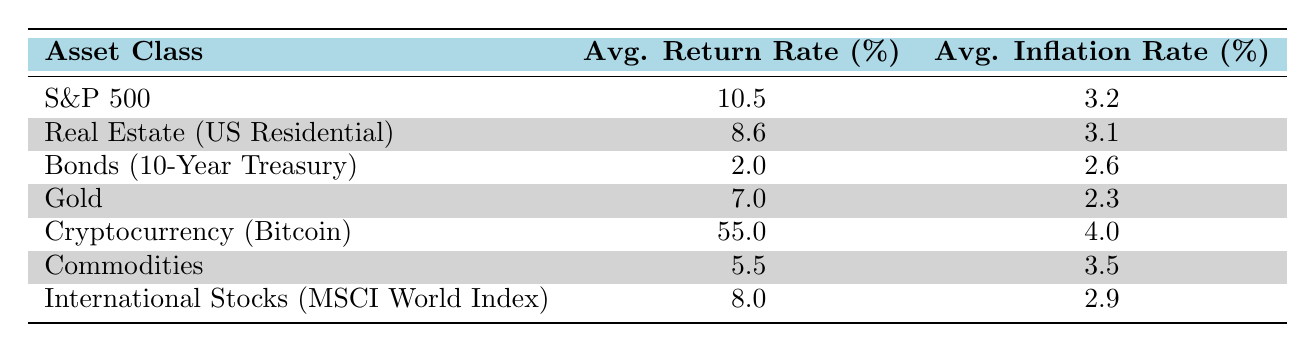What is the average return rate for the S&P 500? The table shows that the average return rate for the S&P 500 is listed as 10.5%.
Answer: 10.5 Which asset class has the highest average inflation rate? By examining the table, the average inflation rates for each asset class are as follows: S&P 500 (3.2), Real Estate (3.1), Bonds (2.6), Gold (2.3), Cryptocurrency (4.0), Commodities (3.5), and International Stocks (2.9). The highest is Cryptocurrency at 4.0%.
Answer: Cryptocurrency Is the average return rate for Real Estate higher than that for Bonds? The table indicates that Real Estate has an average return rate of 8.6% and Bonds have 2.0%. Since 8.6 is greater than 2.0, the answer is yes.
Answer: Yes What is the average difference in average return rates between S&P 500 and Gold? The average return rate for S&P 500 is 10.5% and for Gold is 7.0%. To find the difference, subtract Gold’s rate from S&P 500’s: 10.5 - 7.0 = 3.5.
Answer: 3.5 Does any asset class have an average return rate below 5%? In the table, the only asset class with an average return rate below 5% is Bonds at 2.0%. Therefore, the answer is yes.
Answer: Yes What is the average return rate for all the asset classes combined? First, add all the average return rates: 10.5 + 8.6 + 2.0 + 7.0 + 55.0 + 5.5 + 8.0 = 97.6. Then divide by the number of asset classes (7): 97.6 / 7 ≈ 13.9. Therefore, the average return rate is approximately 13.9%.
Answer: 13.9 Is the average inflation rate for Commodities greater than 3%? The average inflation rate for Commodities is listed as 3.5%, which is indeed greater than 3%. Thus, the answer is yes.
Answer: Yes Which asset class has the lowest return rate? By looking at the average return rates listed, Bonds (10-Year Treasury) has the lowest average return rate of 2.0%.
Answer: Bonds (10-Year Treasury) What is the average return rate of Cryptocurrency and Real Estate combined? The average return rate for Cryptocurrency is 55.0% and for Real Estate is 8.6%. The total is 55.0 + 8.6 = 63.6. Dividing by 2 gives an average of 63.6 / 2 = 31.8.
Answer: 31.8 